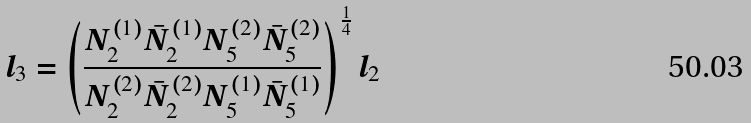Convert formula to latex. <formula><loc_0><loc_0><loc_500><loc_500>l _ { 3 } = \left ( \frac { N _ { 2 } ^ { ( 1 ) } \bar { N } _ { 2 } ^ { ( 1 ) } N _ { 5 } ^ { ( 2 ) } \bar { N } _ { 5 } ^ { ( 2 ) } } { N _ { 2 } ^ { ( 2 ) } \bar { N } _ { 2 } ^ { ( 2 ) } N _ { 5 } ^ { ( 1 ) } \bar { N } _ { 5 } ^ { ( 1 ) } } \right ) ^ { \frac { 1 } { 4 } } l _ { 2 }</formula> 